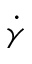<formula> <loc_0><loc_0><loc_500><loc_500>\dot { \gamma }</formula> 